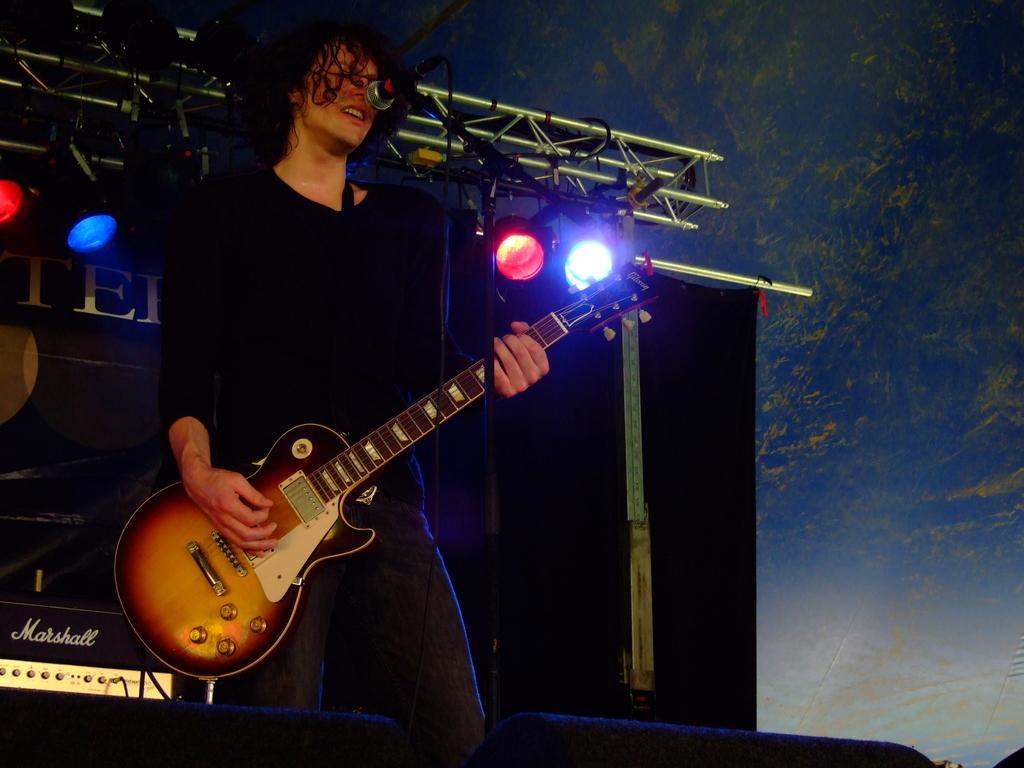Can you describe this image briefly? In this picture, there is a man who is playing a guitar and is also singing. At the back, there's a light. 